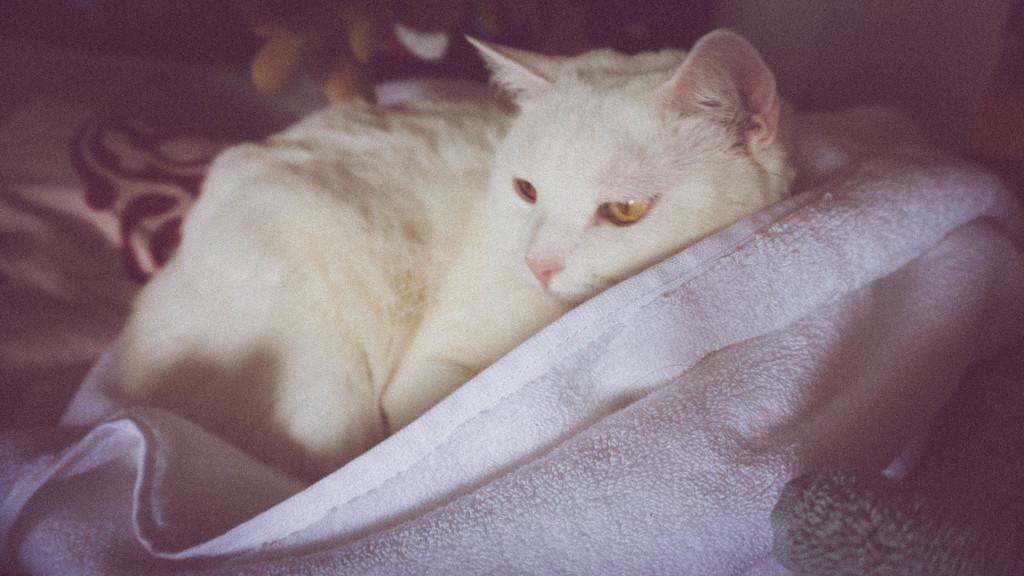In one or two sentences, can you explain what this image depicts? In this image I can see a white color cat is lying on the bed and a blanket. This image is taken in a room. 